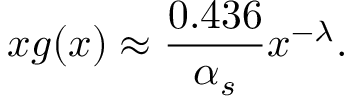<formula> <loc_0><loc_0><loc_500><loc_500>x g ( x ) \approx \frac { 0 . 4 3 6 } { \alpha _ { s } } x ^ { - \lambda } .</formula> 